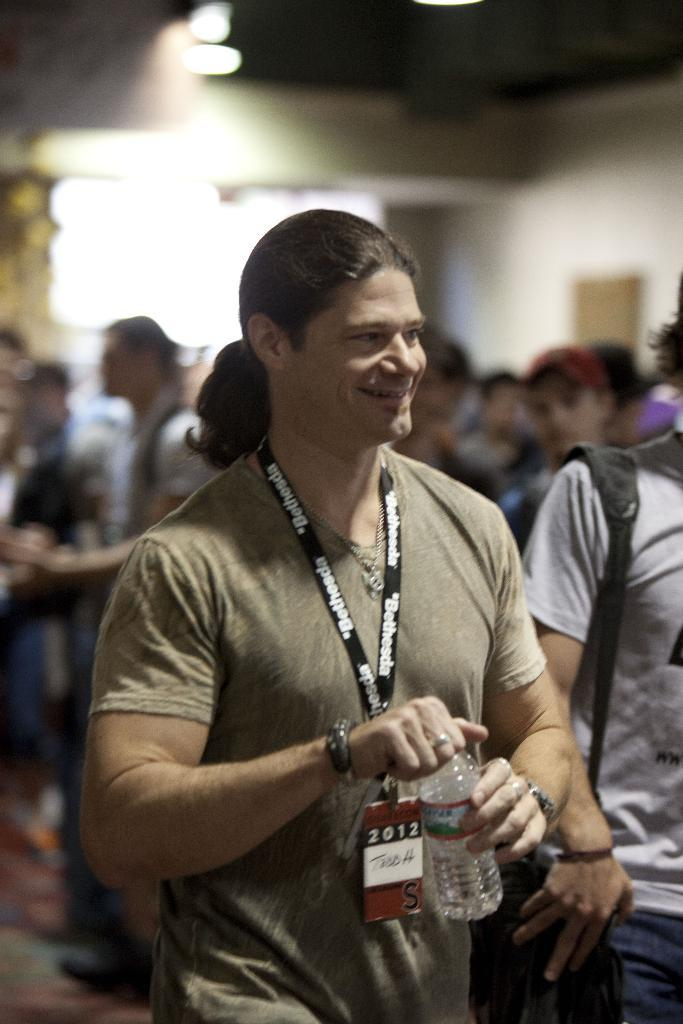Who or what can be seen in the image? There are people in the image. Can you describe any specific features of the image? Yes, there is a light visible at the top of the image. What type of drug is being discussed by the people in the image? There is no indication in the image that the people are discussing any drugs, so it cannot be determined from the picture. 